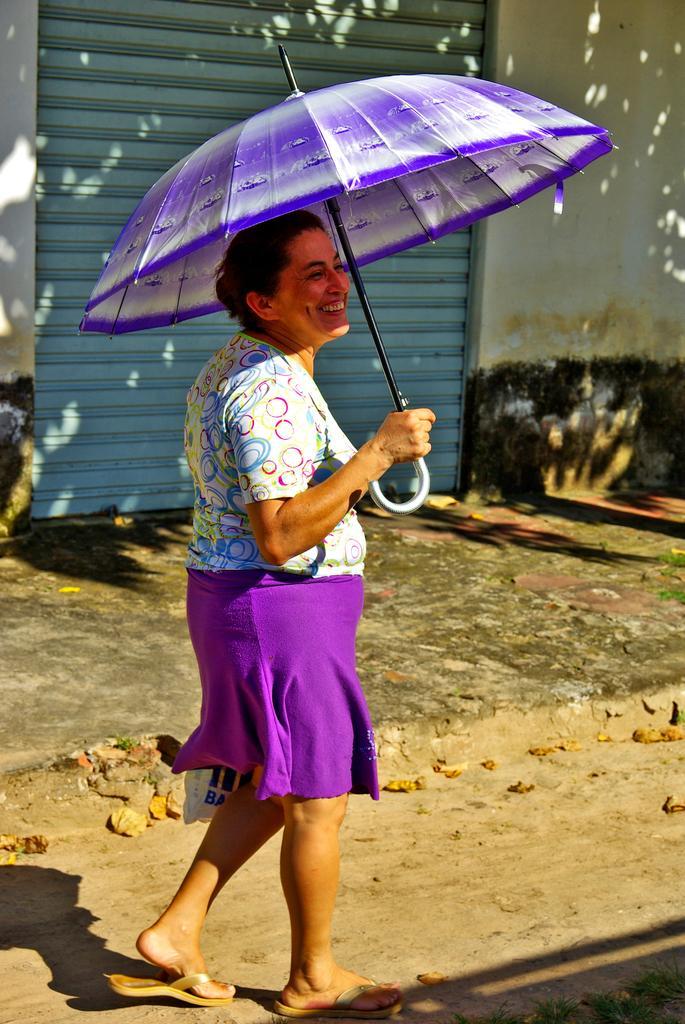Can you describe this image briefly? In the center of the picture there is a woman carrying a bag and holding an umbrella. In the center of the picture there are dry leaves and footpath. In the background there is wall and a shutter. 